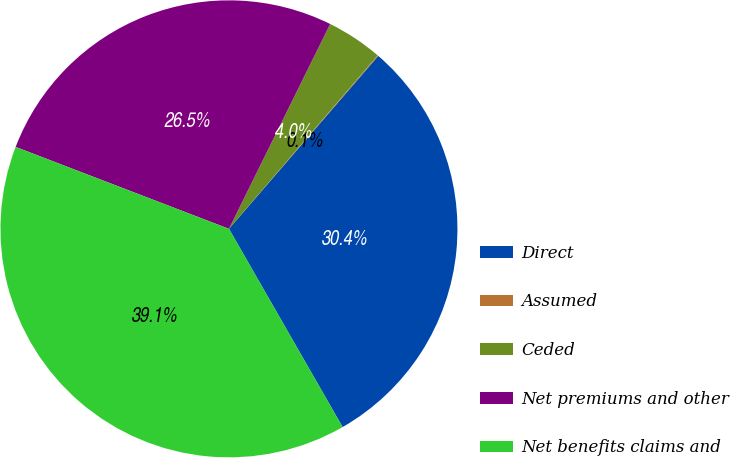Convert chart. <chart><loc_0><loc_0><loc_500><loc_500><pie_chart><fcel>Direct<fcel>Assumed<fcel>Ceded<fcel>Net premiums and other<fcel>Net benefits claims and<nl><fcel>30.38%<fcel>0.06%<fcel>3.97%<fcel>26.47%<fcel>39.12%<nl></chart> 